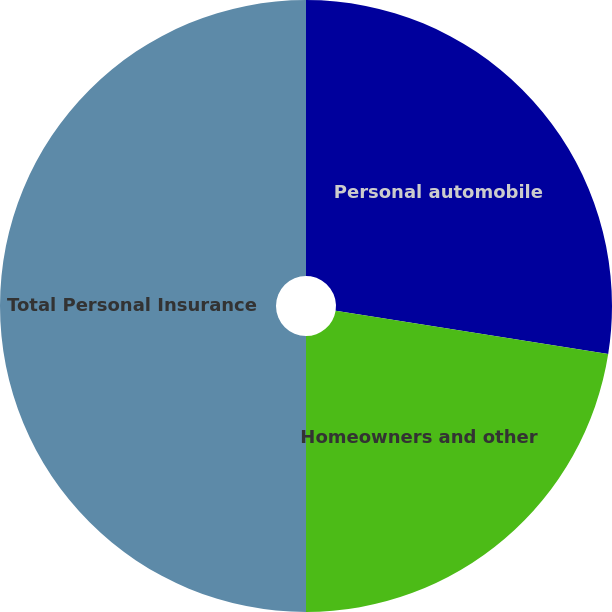Convert chart. <chart><loc_0><loc_0><loc_500><loc_500><pie_chart><fcel>Personal automobile<fcel>Homeowners and other<fcel>Total Personal Insurance<nl><fcel>27.51%<fcel>22.49%<fcel>50.0%<nl></chart> 